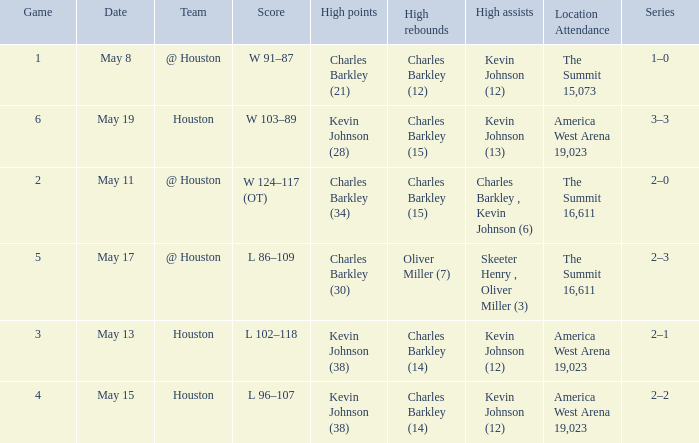How many different high points results are there for the game on May 15? 1.0. 